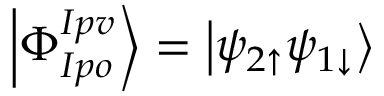Convert formula to latex. <formula><loc_0><loc_0><loc_500><loc_500>\left | \Phi _ { I p o } ^ { I p v } \right > = \left | \psi _ { 2 \uparrow } \psi _ { 1 \downarrow } \right ></formula> 